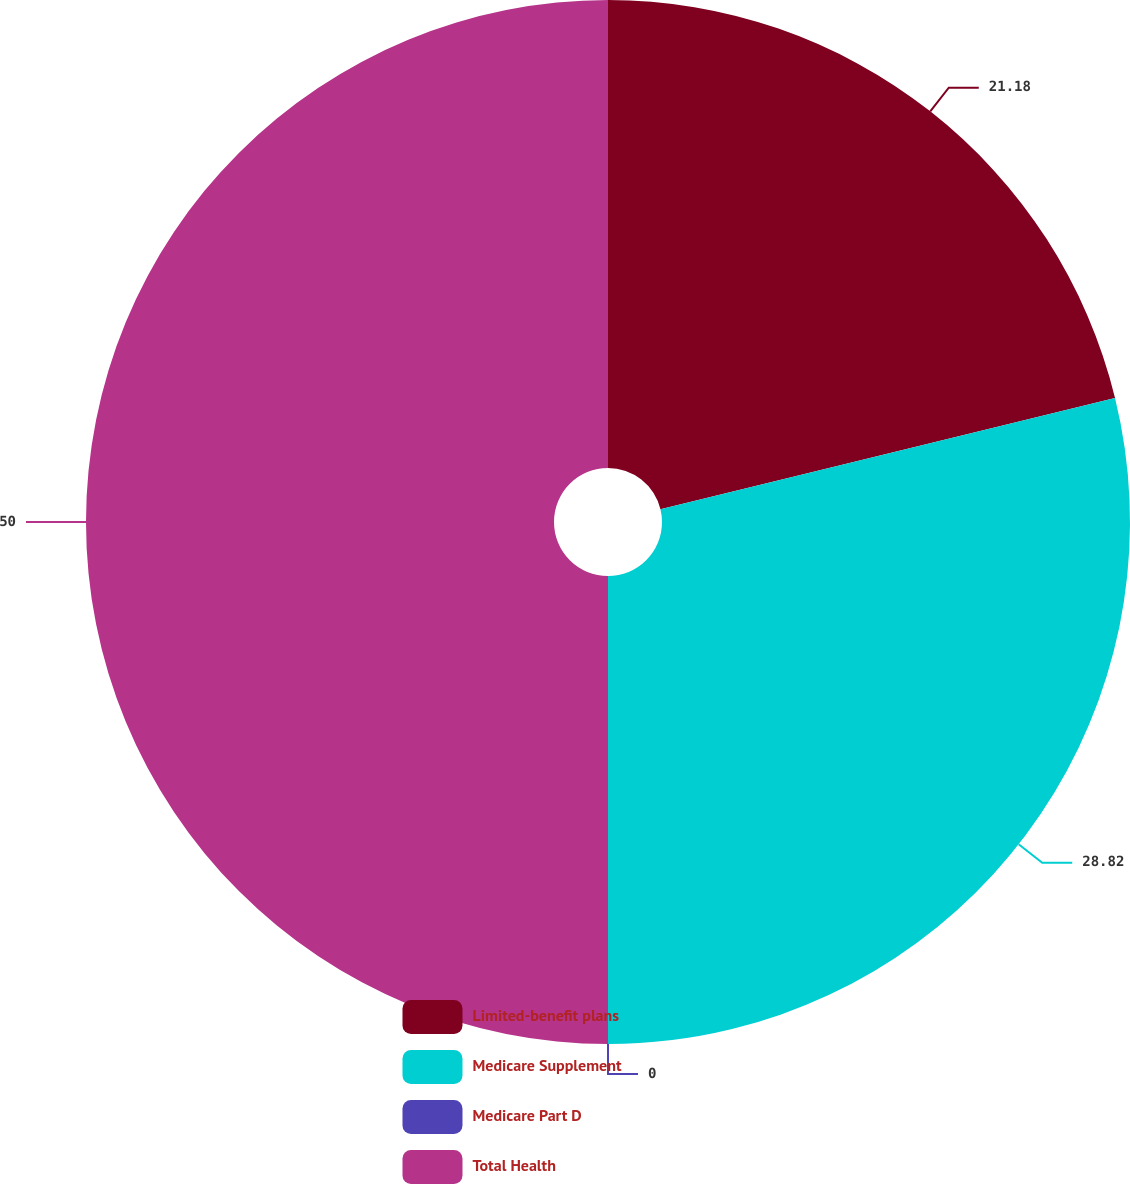Convert chart to OTSL. <chart><loc_0><loc_0><loc_500><loc_500><pie_chart><fcel>Limited-benefit plans<fcel>Medicare Supplement<fcel>Medicare Part D<fcel>Total Health<nl><fcel>21.18%<fcel>28.82%<fcel>0.0%<fcel>50.0%<nl></chart> 